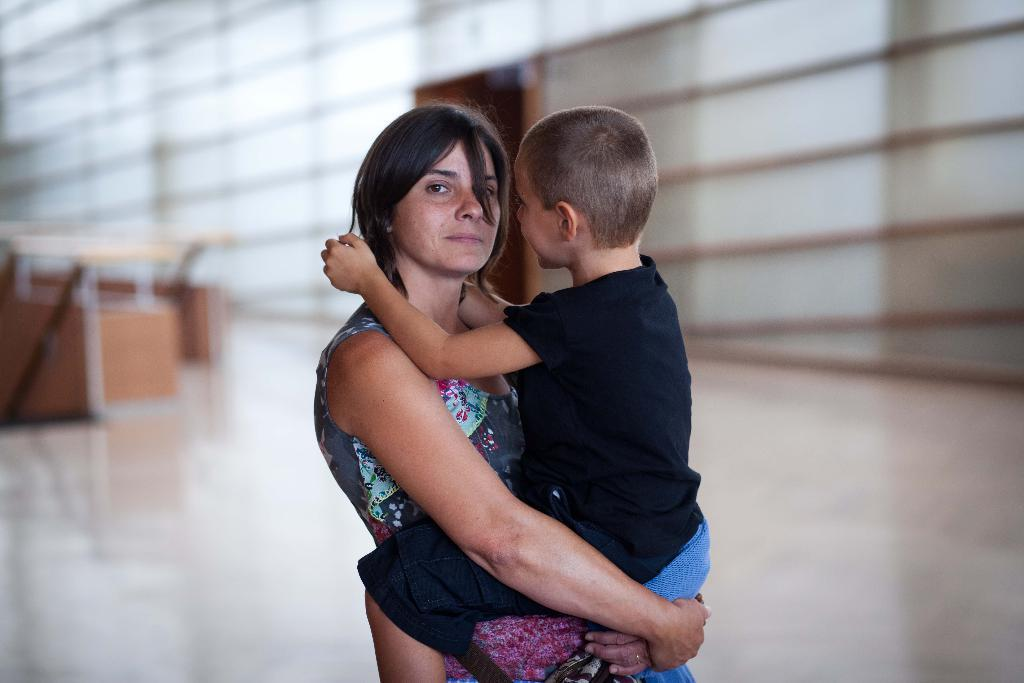Who is the main subject in the image? There is a woman in the image. What is the woman doing in the image? The woman is standing in a building and carrying a kid. Can you describe the background of the image? The background of the image is slightly blurry. What type of pancake is being served in the image? There is no pancake present in the image. How does the ice help to cool down the room in the image? There is no ice present in the image, and the room's temperature is not mentioned. What type of insurance policy is being discussed in the image? There is no mention of insurance or any discussion in the image. 